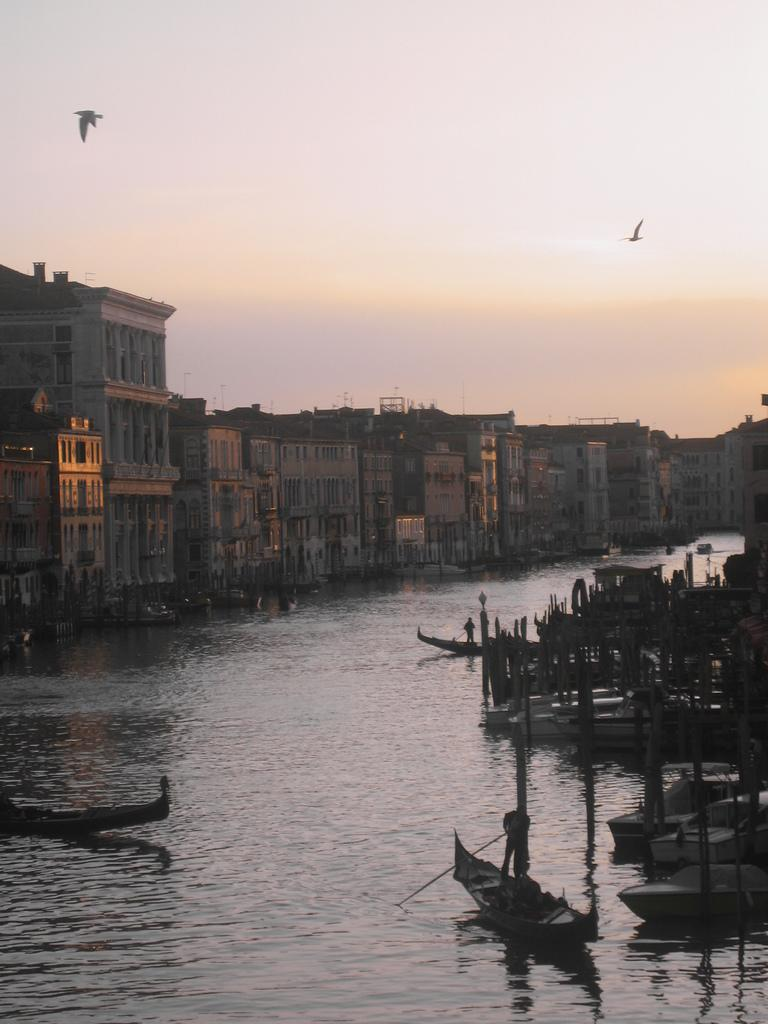What is on the water in the image? There are boats on the water in the image. What can be seen on the left side of the image? There are buildings on the left side of the image. What is happening in the sky in the image? Birds are flying in the image, and clouds are visible in the sky. Can you see a dog playing with a brick in the image? There is no dog or brick present in the image. Who is the aunt in the image? There is no mention of an aunt in the image. 